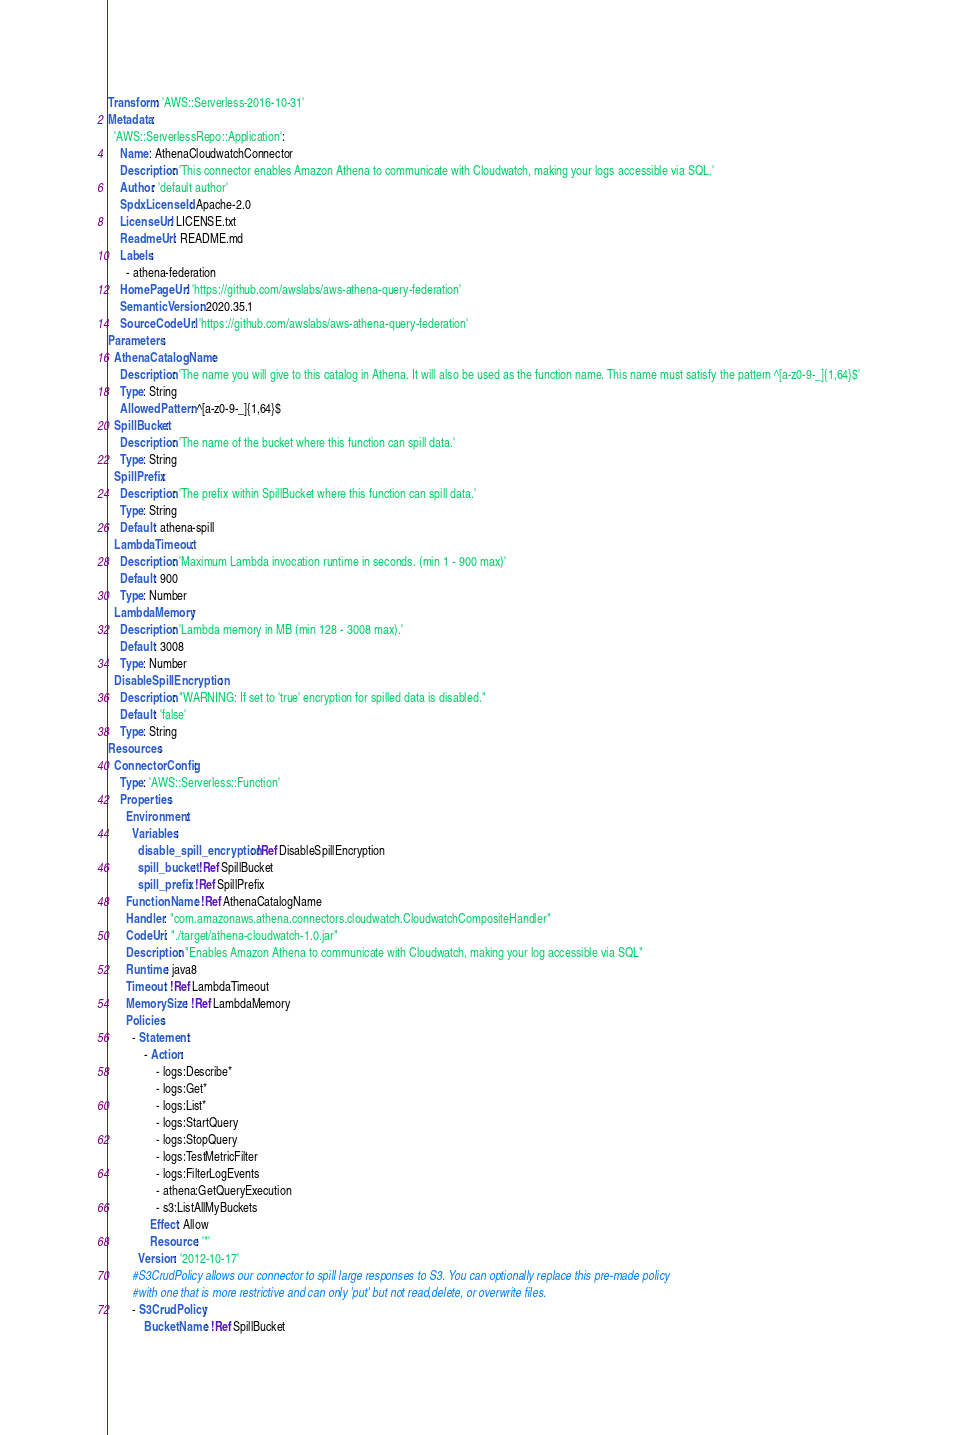<code> <loc_0><loc_0><loc_500><loc_500><_YAML_>Transform: 'AWS::Serverless-2016-10-31'
Metadata:
  'AWS::ServerlessRepo::Application':
    Name: AthenaCloudwatchConnector
    Description: 'This connector enables Amazon Athena to communicate with Cloudwatch, making your logs accessible via SQL.'
    Author: 'default author'
    SpdxLicenseId: Apache-2.0
    LicenseUrl: LICENSE.txt
    ReadmeUrl: README.md
    Labels:
      - athena-federation
    HomePageUrl: 'https://github.com/awslabs/aws-athena-query-federation'
    SemanticVersion: 2020.35.1
    SourceCodeUrl: 'https://github.com/awslabs/aws-athena-query-federation'
Parameters:
  AthenaCatalogName:
    Description: 'The name you will give to this catalog in Athena. It will also be used as the function name. This name must satisfy the pattern ^[a-z0-9-_]{1,64}$'
    Type: String
    AllowedPattern: ^[a-z0-9-_]{1,64}$
  SpillBucket:
    Description: 'The name of the bucket where this function can spill data.'
    Type: String
  SpillPrefix:
    Description: 'The prefix within SpillBucket where this function can spill data.'
    Type: String
    Default: athena-spill
  LambdaTimeout:
    Description: 'Maximum Lambda invocation runtime in seconds. (min 1 - 900 max)'
    Default: 900
    Type: Number
  LambdaMemory:
    Description: 'Lambda memory in MB (min 128 - 3008 max).'
    Default: 3008
    Type: Number
  DisableSpillEncryption:
    Description: "WARNING: If set to 'true' encryption for spilled data is disabled."
    Default: 'false'
    Type: String
Resources:
  ConnectorConfig:
    Type: 'AWS::Serverless::Function'
    Properties:
      Environment:
        Variables:
          disable_spill_encryption: !Ref DisableSpillEncryption
          spill_bucket: !Ref SpillBucket
          spill_prefix: !Ref SpillPrefix
      FunctionName: !Ref AthenaCatalogName
      Handler: "com.amazonaws.athena.connectors.cloudwatch.CloudwatchCompositeHandler"
      CodeUri: "./target/athena-cloudwatch-1.0.jar"
      Description: "Enables Amazon Athena to communicate with Cloudwatch, making your log accessible via SQL"
      Runtime: java8
      Timeout: !Ref LambdaTimeout
      MemorySize: !Ref LambdaMemory
      Policies:
        - Statement:
            - Action:
                - logs:Describe*
                - logs:Get*
                - logs:List*
                - logs:StartQuery
                - logs:StopQuery
                - logs:TestMetricFilter
                - logs:FilterLogEvents
                - athena:GetQueryExecution
                - s3:ListAllMyBuckets
              Effect: Allow
              Resource: '*'
          Version: '2012-10-17'
        #S3CrudPolicy allows our connector to spill large responses to S3. You can optionally replace this pre-made policy
        #with one that is more restrictive and can only 'put' but not read,delete, or overwrite files.
        - S3CrudPolicy:
            BucketName: !Ref SpillBucket</code> 